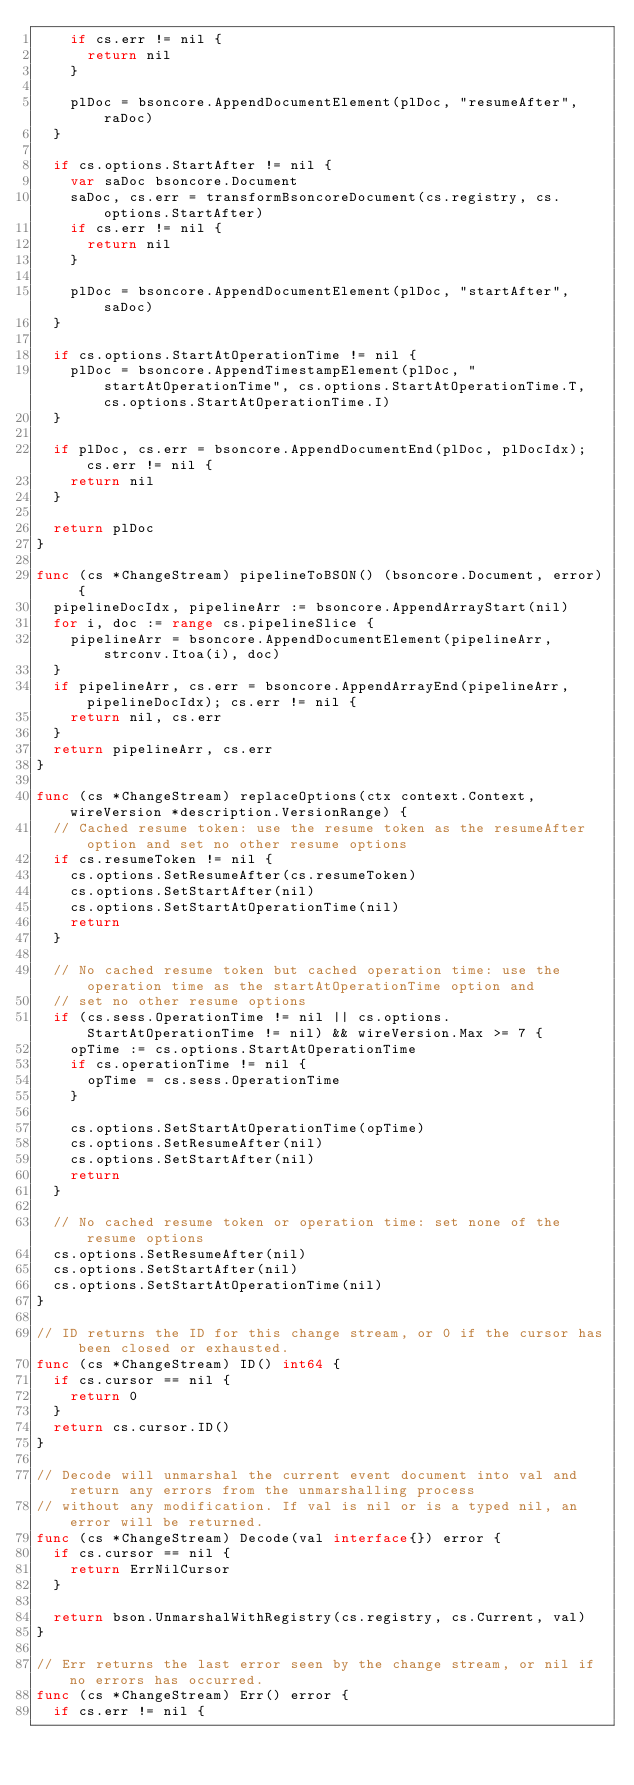<code> <loc_0><loc_0><loc_500><loc_500><_Go_>		if cs.err != nil {
			return nil
		}

		plDoc = bsoncore.AppendDocumentElement(plDoc, "resumeAfter", raDoc)
	}

	if cs.options.StartAfter != nil {
		var saDoc bsoncore.Document
		saDoc, cs.err = transformBsoncoreDocument(cs.registry, cs.options.StartAfter)
		if cs.err != nil {
			return nil
		}

		plDoc = bsoncore.AppendDocumentElement(plDoc, "startAfter", saDoc)
	}

	if cs.options.StartAtOperationTime != nil {
		plDoc = bsoncore.AppendTimestampElement(plDoc, "startAtOperationTime", cs.options.StartAtOperationTime.T, cs.options.StartAtOperationTime.I)
	}

	if plDoc, cs.err = bsoncore.AppendDocumentEnd(plDoc, plDocIdx); cs.err != nil {
		return nil
	}

	return plDoc
}

func (cs *ChangeStream) pipelineToBSON() (bsoncore.Document, error) {
	pipelineDocIdx, pipelineArr := bsoncore.AppendArrayStart(nil)
	for i, doc := range cs.pipelineSlice {
		pipelineArr = bsoncore.AppendDocumentElement(pipelineArr, strconv.Itoa(i), doc)
	}
	if pipelineArr, cs.err = bsoncore.AppendArrayEnd(pipelineArr, pipelineDocIdx); cs.err != nil {
		return nil, cs.err
	}
	return pipelineArr, cs.err
}

func (cs *ChangeStream) replaceOptions(ctx context.Context, wireVersion *description.VersionRange) {
	// Cached resume token: use the resume token as the resumeAfter option and set no other resume options
	if cs.resumeToken != nil {
		cs.options.SetResumeAfter(cs.resumeToken)
		cs.options.SetStartAfter(nil)
		cs.options.SetStartAtOperationTime(nil)
		return
	}

	// No cached resume token but cached operation time: use the operation time as the startAtOperationTime option and
	// set no other resume options
	if (cs.sess.OperationTime != nil || cs.options.StartAtOperationTime != nil) && wireVersion.Max >= 7 {
		opTime := cs.options.StartAtOperationTime
		if cs.operationTime != nil {
			opTime = cs.sess.OperationTime
		}

		cs.options.SetStartAtOperationTime(opTime)
		cs.options.SetResumeAfter(nil)
		cs.options.SetStartAfter(nil)
		return
	}

	// No cached resume token or operation time: set none of the resume options
	cs.options.SetResumeAfter(nil)
	cs.options.SetStartAfter(nil)
	cs.options.SetStartAtOperationTime(nil)
}

// ID returns the ID for this change stream, or 0 if the cursor has been closed or exhausted.
func (cs *ChangeStream) ID() int64 {
	if cs.cursor == nil {
		return 0
	}
	return cs.cursor.ID()
}

// Decode will unmarshal the current event document into val and return any errors from the unmarshalling process
// without any modification. If val is nil or is a typed nil, an error will be returned.
func (cs *ChangeStream) Decode(val interface{}) error {
	if cs.cursor == nil {
		return ErrNilCursor
	}

	return bson.UnmarshalWithRegistry(cs.registry, cs.Current, val)
}

// Err returns the last error seen by the change stream, or nil if no errors has occurred.
func (cs *ChangeStream) Err() error {
	if cs.err != nil {</code> 